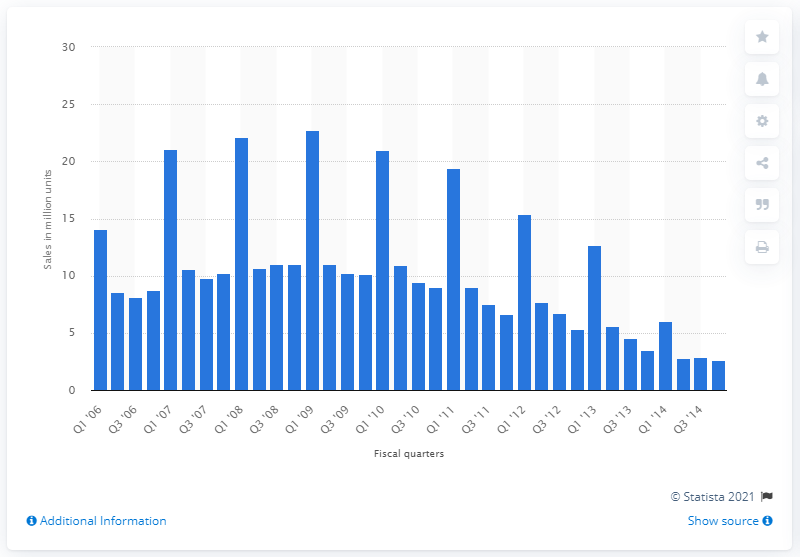Indicate a few pertinent items in this graphic. In the first quarter of the 2006 fiscal year, Apple sold 14,040 iPods. 